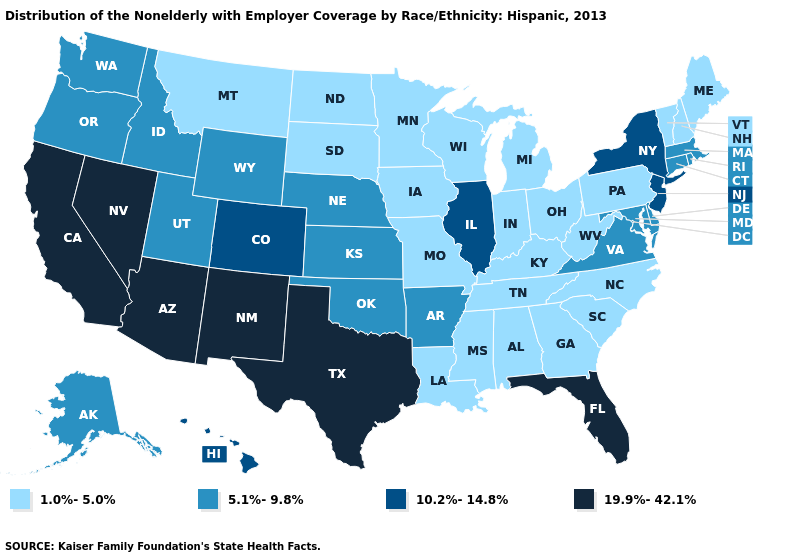Does Ohio have the highest value in the MidWest?
Write a very short answer. No. What is the value of Missouri?
Keep it brief. 1.0%-5.0%. Among the states that border Idaho , does Oregon have the lowest value?
Short answer required. No. Among the states that border Iowa , which have the highest value?
Be succinct. Illinois. Does Arizona have the highest value in the West?
Concise answer only. Yes. What is the value of Kansas?
Give a very brief answer. 5.1%-9.8%. Which states have the highest value in the USA?
Keep it brief. Arizona, California, Florida, Nevada, New Mexico, Texas. Which states hav the highest value in the Northeast?
Keep it brief. New Jersey, New York. Does Oklahoma have the highest value in the South?
Short answer required. No. What is the highest value in states that border Rhode Island?
Concise answer only. 5.1%-9.8%. What is the value of Virginia?
Give a very brief answer. 5.1%-9.8%. Which states have the lowest value in the USA?
Concise answer only. Alabama, Georgia, Indiana, Iowa, Kentucky, Louisiana, Maine, Michigan, Minnesota, Mississippi, Missouri, Montana, New Hampshire, North Carolina, North Dakota, Ohio, Pennsylvania, South Carolina, South Dakota, Tennessee, Vermont, West Virginia, Wisconsin. What is the value of Idaho?
Quick response, please. 5.1%-9.8%. What is the value of New Hampshire?
Concise answer only. 1.0%-5.0%. 